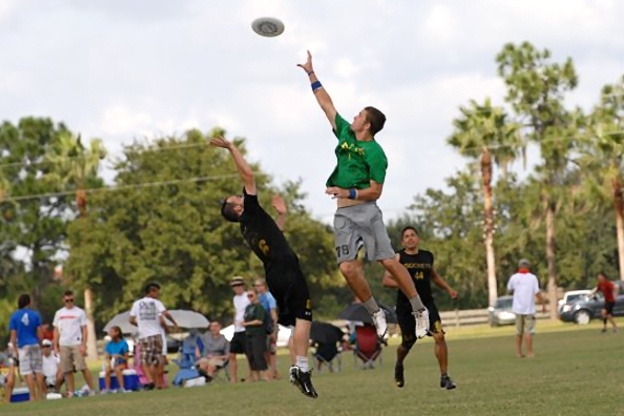Describe the objects in this image and their specific colors. I can see people in white, gray, black, and darkgreen tones, people in white, black, gray, tan, and olive tones, people in white, black, maroon, and gray tones, people in white, darkgray, gray, maroon, and lavender tones, and people in white, gray, darkgray, and blue tones in this image. 